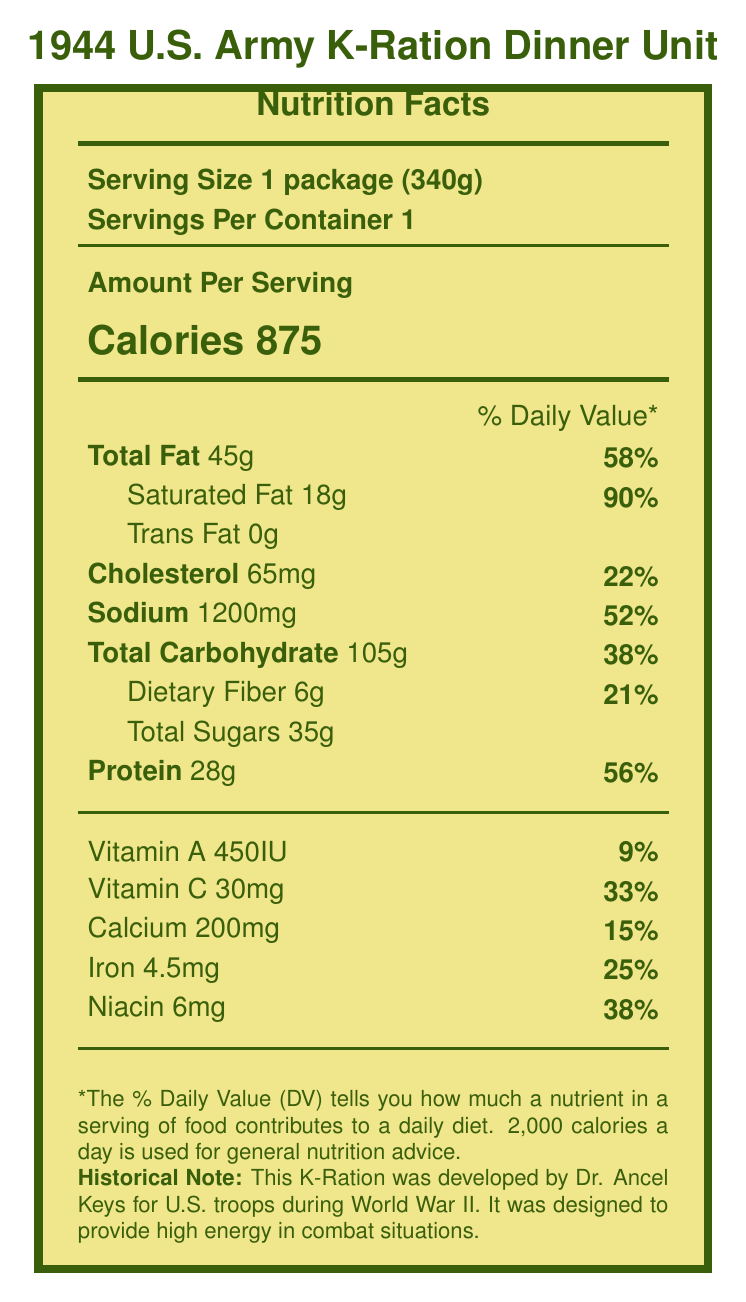what is the serving size for the 1944 U.S. Army K-Ration Dinner Unit? The serving size is listed as "1 package (340g)" at the top of the Nutrition Facts Label.
Answer: 1 package (340g) how many calories does one serving of the 1944 U.S. Army K-Ration Dinner Unit contain? The calorie content is listed as "Calories 875" under the "Amount Per Serving" section.
Answer: 875 what is the percentage of the Daily Value for saturated fat in the 1944 U.S. Army K-Ration Dinner Unit? The percentage of the Daily Value for saturated fat is found next to the "Saturated Fat 18g" entry as "90%".
Answer: 90% how much protein is there in one serving? The protein amount is listed as "Protein 28g" in the nutritional facts.
Answer: 28g what vitamins and minerals are included in the Nutrition Facts Label of the 1944 U.S. Army K-Ration Dinner Unit? The vitamins and minerals listed are Vitamin A, Vitamin C, Calcium, Iron, and Niacin.
Answer: Vitamin A, Vitamin C, Calcium, Iron, Niacin what year was the 1944 U.S. Army K-Ration Dinner Unit developed? A. 1918 B. 1944 C. 1950 D. 1965 The historical significance note mentions that this ration was developed in 1944.
Answer: B what is not included in the nutritional content of the 1944 U.S. Army K-Ration Dinner Unit? A. Packets of salt and pepper B. Instant coffee C. Cigarettes D. Sugar cubes The unique features note mentions that cigarettes are included but not factored into the nutritional content.
Answer: C does the 1944 U.S. Army K-Ration Dinner Unit have trans fat? The document states "Trans Fat 0g", indicating no trans fat is present.
Answer: No summarize the main purpose and content of the 1944 U.S. Army K-Ration Dinner Unit's Nutrition Facts Label. The document details the nutritional content and historical significance of the 1944 U.S. Army K-Ration Dinner Unit. Each serving provides 875 calories and includes macronutrients, vitamins, and minerals tailored for soldiers' needs during World War II. The packaging also contained practical items such as Halazone tablets for water purification and cigarettes.
Answer: The Nutrition Facts Label for the 1944 U.S. Army K-Ration Dinner Unit provides detailed nutritional information for a single serving package. It includes data on calories, macronutrients (fats, carbohydrates, protein), vitamins, and minerals. This ration was developed during World War II to provide high energy for troops in combat situations and contains unique items like Halazone tablets and a specially formulated chocolate bar. The label also includes historical notes and collector guidance. how many grams of dietary fiber are in one serving of the 1944 U.S. Army K-Ration Dinner Unit? The dietary fiber content is listed as "Dietary Fiber 6g".
Answer: 6g how long do you think it took to develop the 1944 U.S. Army K-Ration Dinner Unit? The document does not provide any information about the development time for the ration unit.
Answer: Cannot be determined 